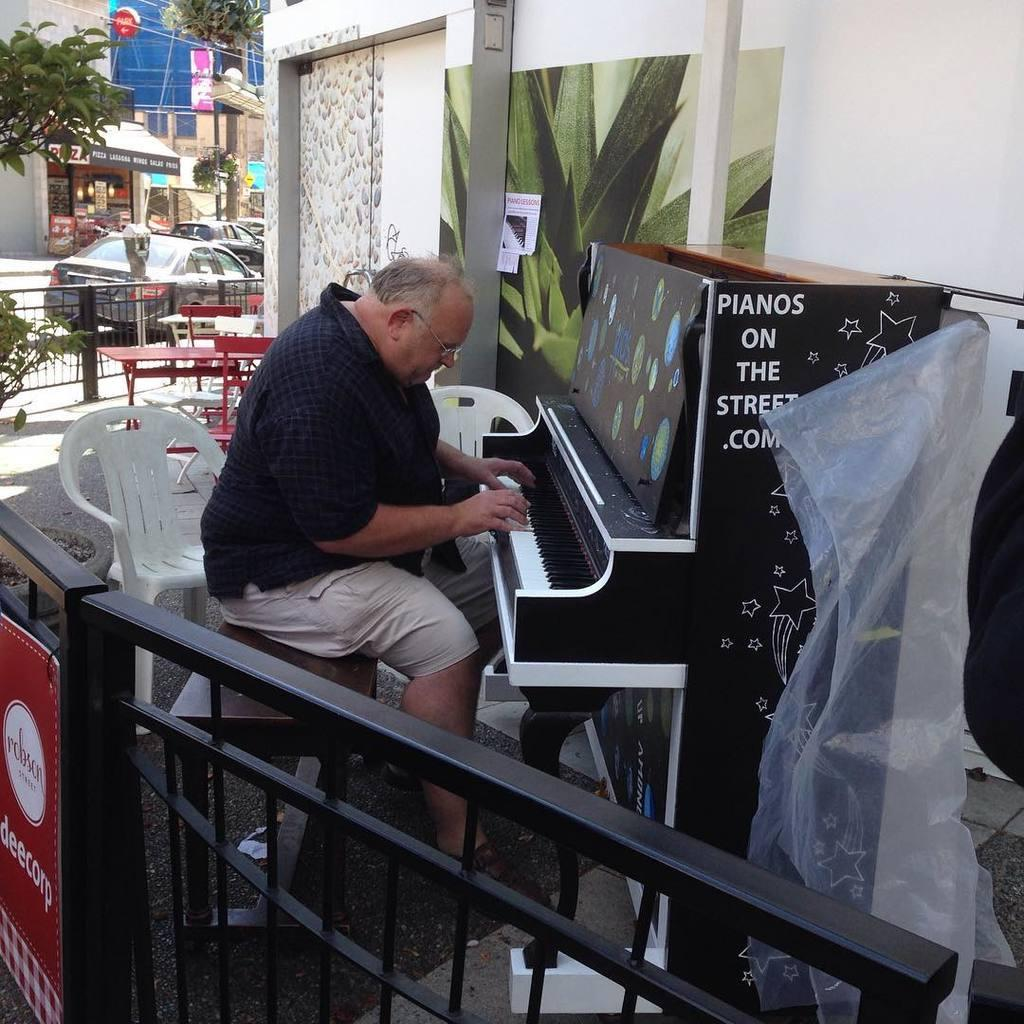What is the man in the image doing? The man is playing a piano in the image. Where is the man sitting while playing the piano? The man is sitting in a chair in the image. Can you describe the location of the piano? The piano is on the street in the image. What can be seen in the background of the image? In the background of the image, there are chairs, plants, a tree, buildings, cars, name boards, and iron rods. What page of the book is the man turning in the image? There is no book present in the image, so it is not possible to determine which page the man might be turning. 